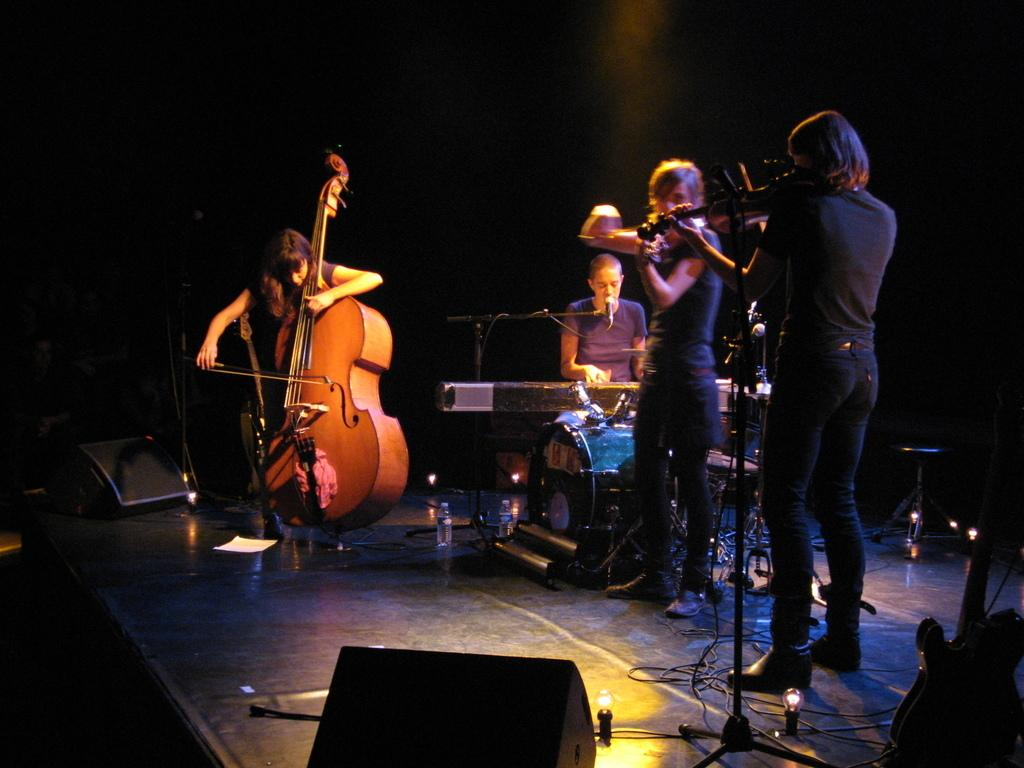What are the people in the image doing? The people in the image are playing musical instruments. Where are the people playing their instruments? The people are on a stage. What can be seen in the background of the image? There is a black wall in the background of the image. How many trucks are parked behind the people playing musical instruments in the image? There are no trucks visible in the image; it only shows people playing musical instruments on a stage with a black wall in the background. 